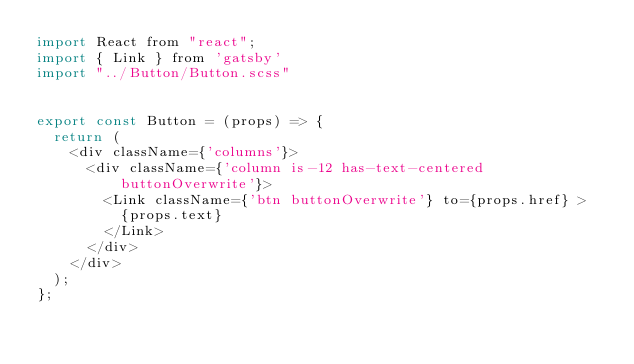Convert code to text. <code><loc_0><loc_0><loc_500><loc_500><_JavaScript_>import React from "react";
import { Link } from 'gatsby'
import "../Button/Button.scss"


export const Button = (props) => {
  return (
    <div className={'columns'}>
      <div className={'column is-12 has-text-centered buttonOverwrite'}>
        <Link className={'btn buttonOverwrite'} to={props.href} >
          {props.text}
        </Link>
      </div>
    </div>
  );
};
</code> 